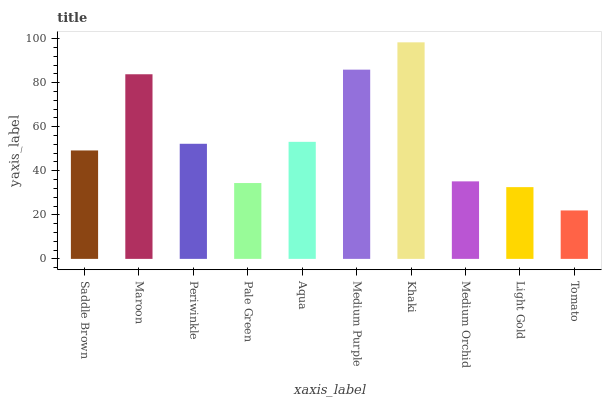Is Tomato the minimum?
Answer yes or no. Yes. Is Khaki the maximum?
Answer yes or no. Yes. Is Maroon the minimum?
Answer yes or no. No. Is Maroon the maximum?
Answer yes or no. No. Is Maroon greater than Saddle Brown?
Answer yes or no. Yes. Is Saddle Brown less than Maroon?
Answer yes or no. Yes. Is Saddle Brown greater than Maroon?
Answer yes or no. No. Is Maroon less than Saddle Brown?
Answer yes or no. No. Is Periwinkle the high median?
Answer yes or no. Yes. Is Saddle Brown the low median?
Answer yes or no. Yes. Is Khaki the high median?
Answer yes or no. No. Is Khaki the low median?
Answer yes or no. No. 